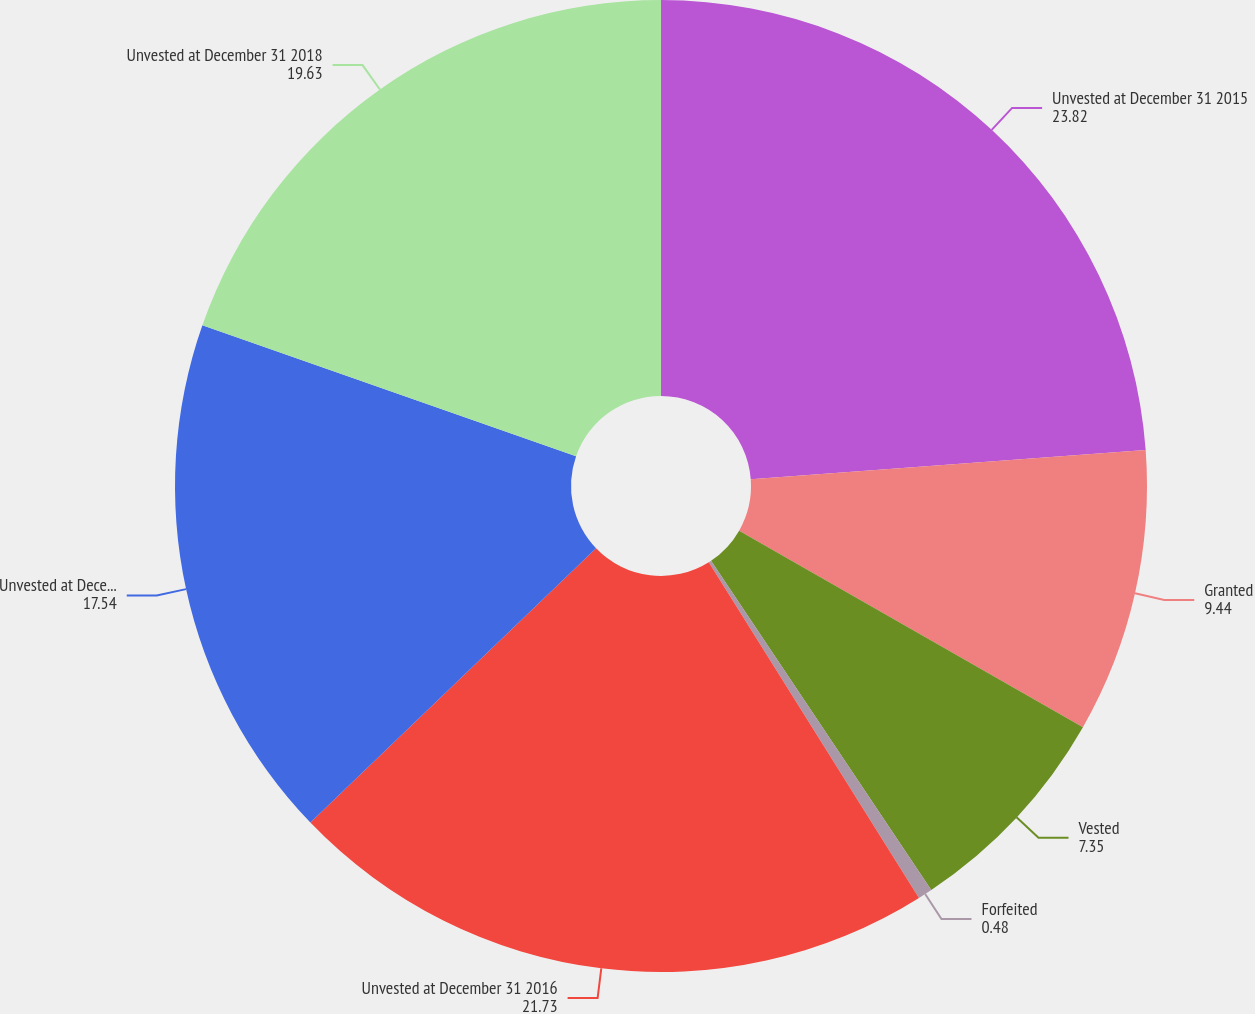<chart> <loc_0><loc_0><loc_500><loc_500><pie_chart><fcel>Unvested at December 31 2015<fcel>Granted<fcel>Vested<fcel>Forfeited<fcel>Unvested at December 31 2016<fcel>Unvested at December 31 2017<fcel>Unvested at December 31 2018<nl><fcel>23.82%<fcel>9.44%<fcel>7.35%<fcel>0.48%<fcel>21.73%<fcel>17.54%<fcel>19.63%<nl></chart> 